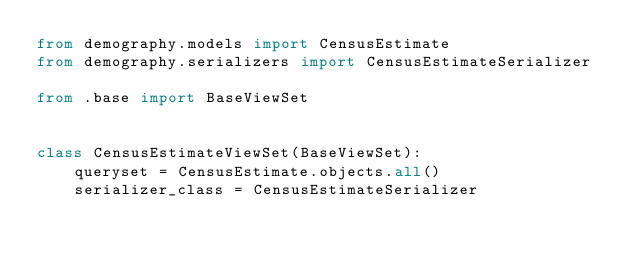<code> <loc_0><loc_0><loc_500><loc_500><_Python_>from demography.models import CensusEstimate
from demography.serializers import CensusEstimateSerializer

from .base import BaseViewSet


class CensusEstimateViewSet(BaseViewSet):
    queryset = CensusEstimate.objects.all()
    serializer_class = CensusEstimateSerializer
</code> 